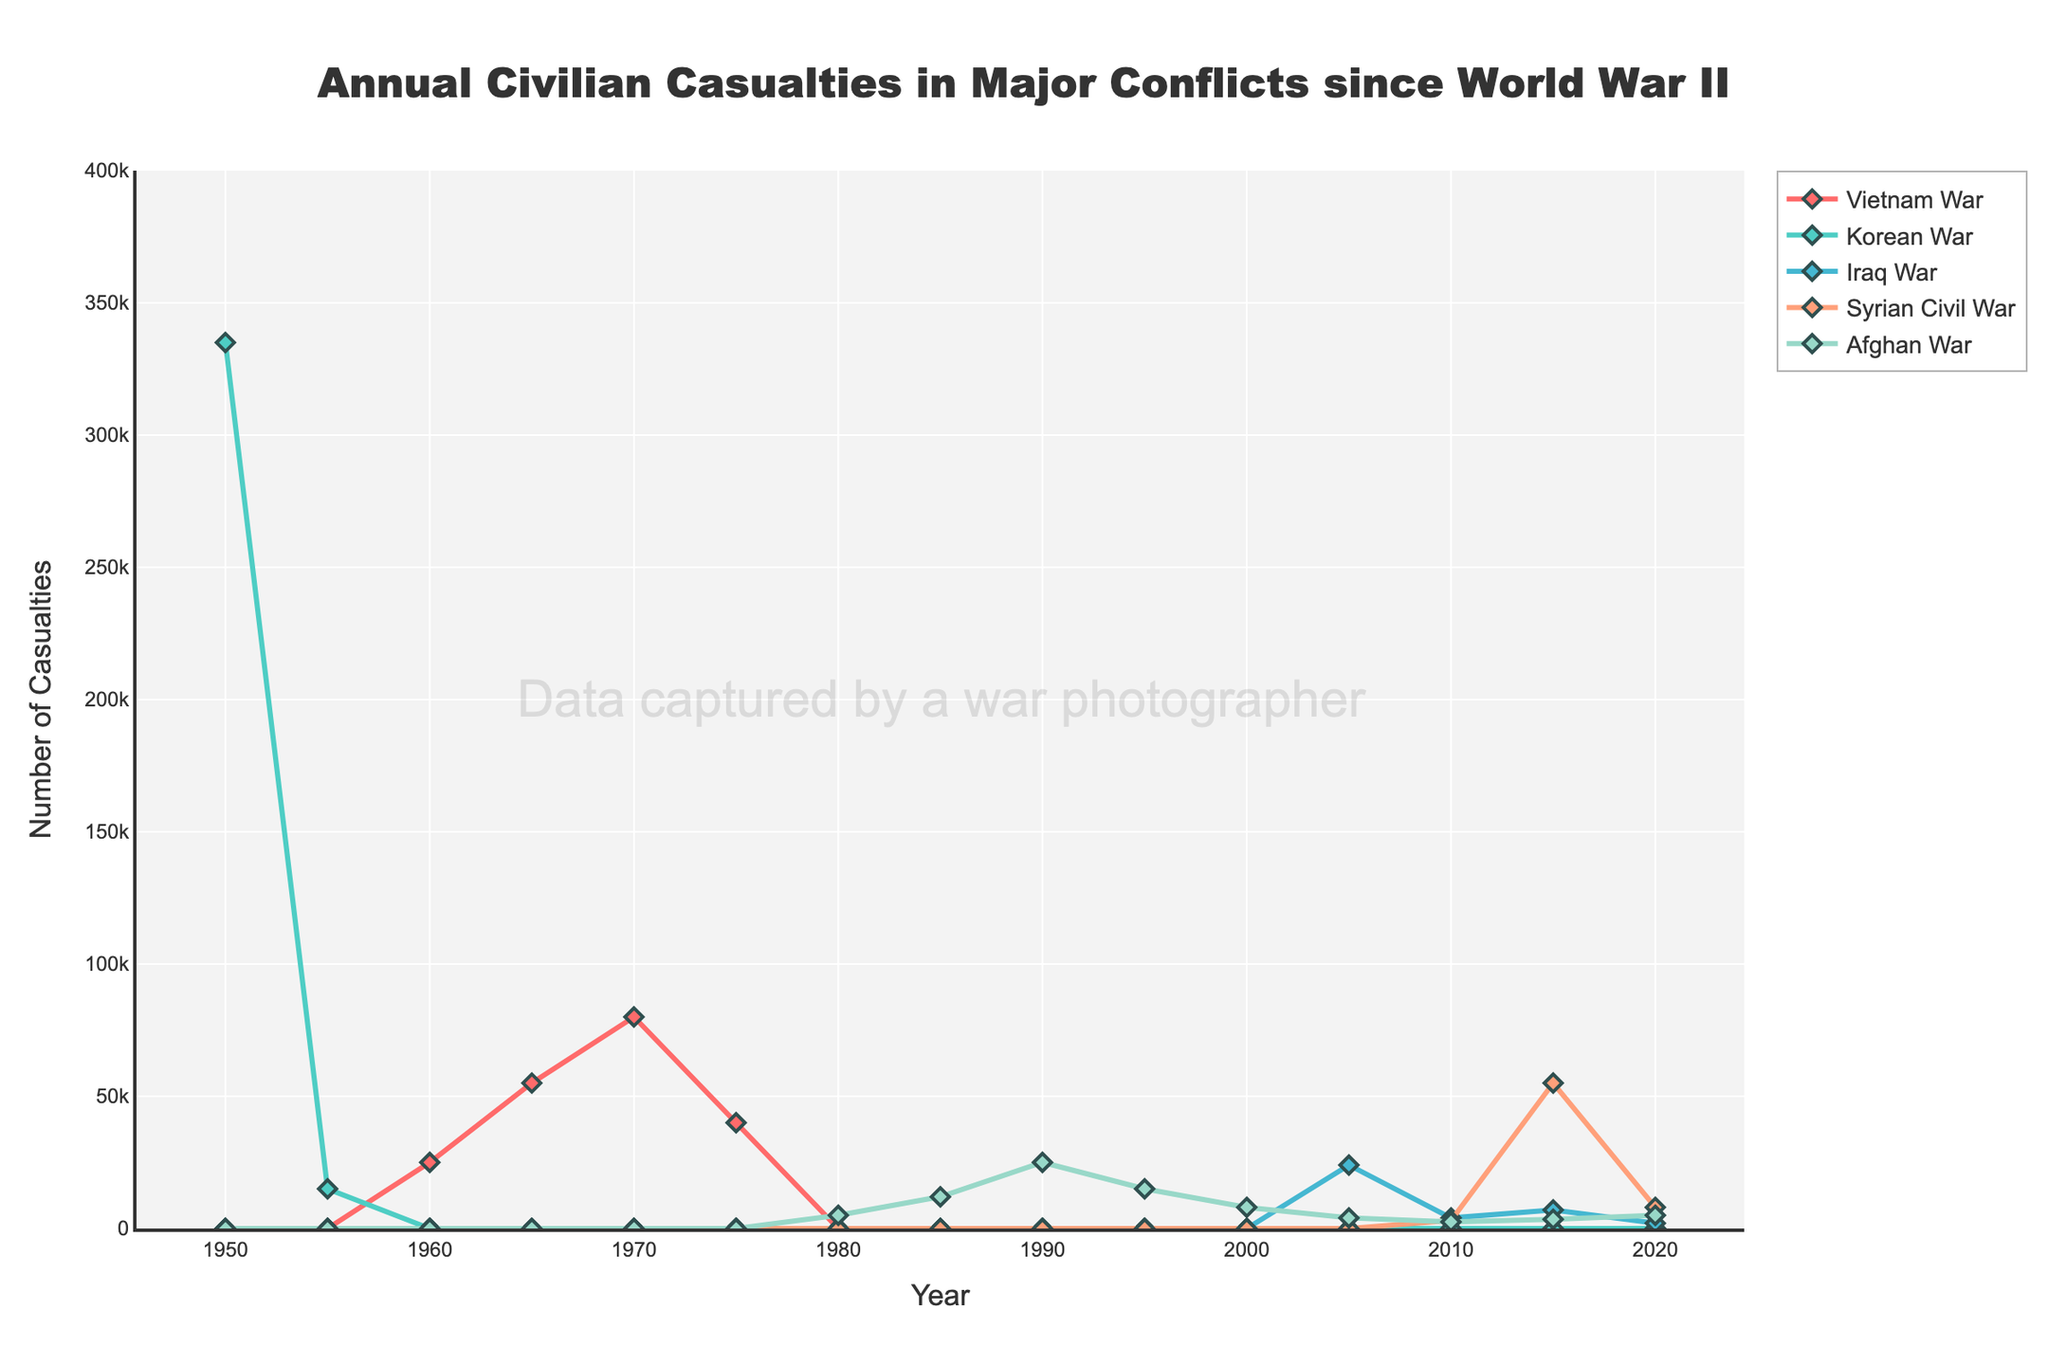What year did the Syrian Civil War record the highest number of civilian casualties? By inspecting the Syrian Civil War line on the plot (orange line), we see that the peak occurs in 2015.
Answer: 2015 Which conflict had the highest number of civilian casualties in the year 1950? Referring to the plot and comparing all conflicts for the year 1950, the Korean War had the highest number of civilian casualties at 335,000.
Answer: Korean War In which years did the Vietnam War have more civilian casualties than the Korean War? The Vietnam War line (green) appears after the Korean War ended, showing peaks in 1960, 1965, 1970, and 1975. Therefore, these are the years where the Vietnam War had casualties, whereas the Korean War shows no casualties after 1955.
Answer: 1960, 1965, 1970, 1975 Compare the civilian casualties of the Vietnam War in 1970 to those in 1975. Did the number increase or decrease? Observing the green line for the Vietnam War, casualties in 1970 were 80,000 while in 1975 they were 40,000, showing a decrease.
Answer: Decrease Which conflict had the longest span of recorded civilian casualties? By examining the years each conflict appears in, the Afghan War (light blue line) has the longest span, starting in 1980 and continuing through 2020.
Answer: Afghan War What was the combined total of civilian casualties in 2010 for the Iraq War, Syrian Civil War, and Afghan War? The casualties in 2010 are: Iraq War 4,000, Syrian Civil War 3,000, and Afghan War 2,500. Summing them: 4,000 + 3,000 + 2,500 = 9,500.
Answer: 9,500 Between 1985 and 1990, how did civilian casualties in the Afghan War change? Observing the light blue line for Afghan War between 1985 and 1990, casualties increased from 12,000 in 1985 to 25,000 in 1990.
Answer: Increased Which conflict experienced a peak and then a significant decline in civilian casualties within a span of 5 years? The green line for the Vietnam War shows a peak at 80,000 casualties in 1970 and declines to 40,000 by 1975.
Answer: Vietnam War 